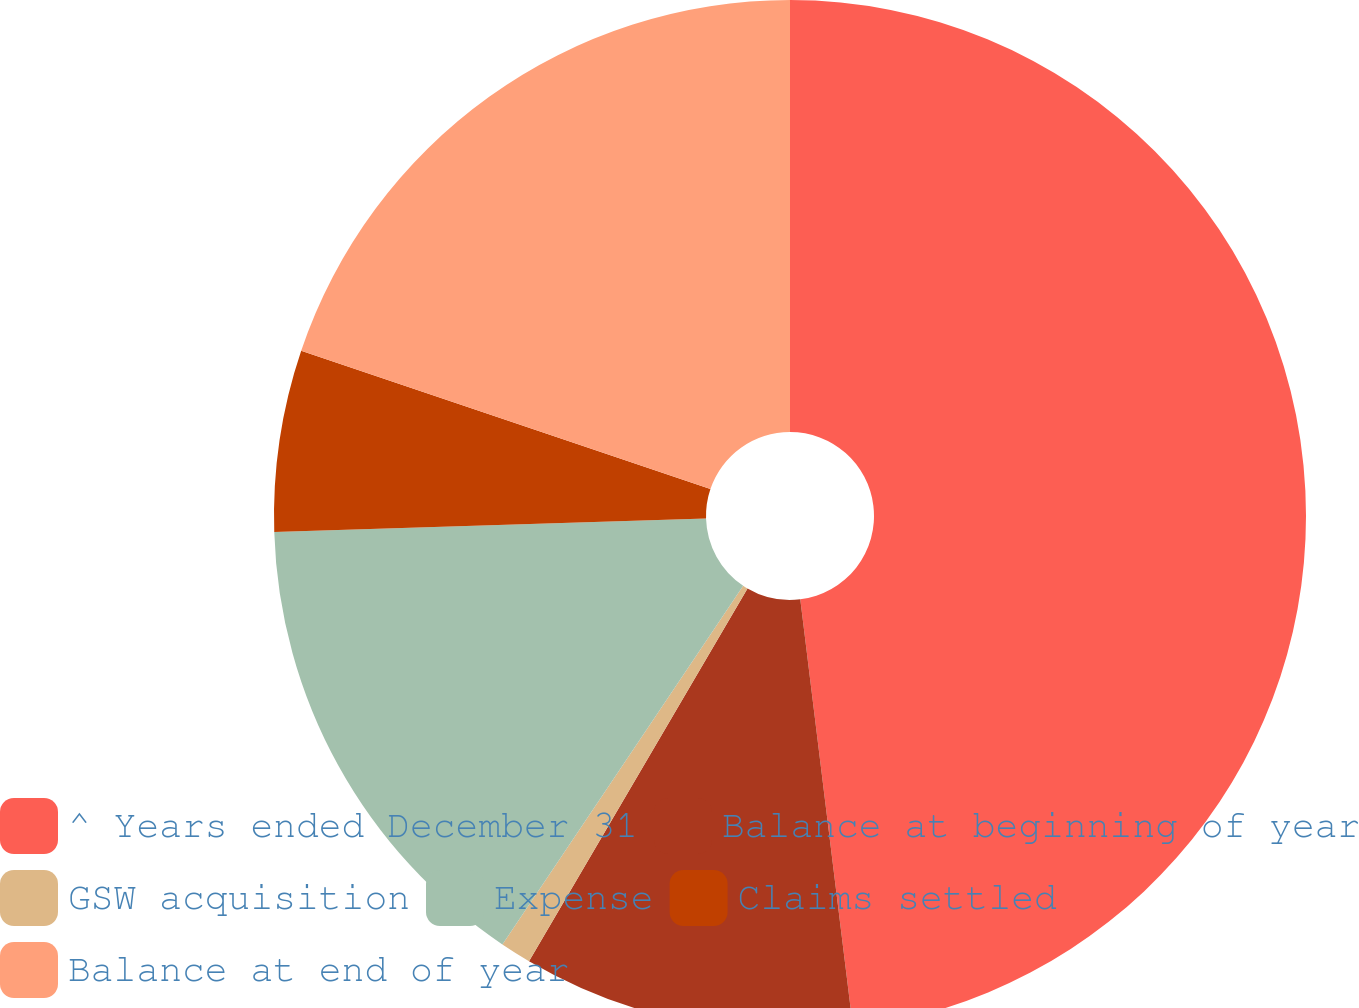Convert chart. <chart><loc_0><loc_0><loc_500><loc_500><pie_chart><fcel>^ Years ended December 31<fcel>Balance at beginning of year<fcel>GSW acquisition<fcel>Expense<fcel>Claims settled<fcel>Balance at end of year<nl><fcel>48.05%<fcel>10.39%<fcel>0.97%<fcel>15.1%<fcel>5.68%<fcel>19.81%<nl></chart> 